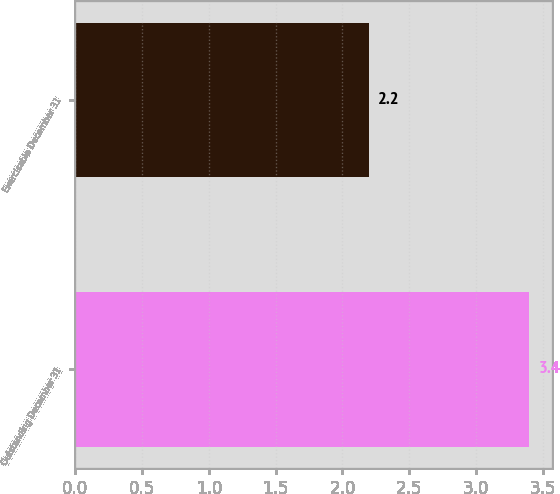Convert chart. <chart><loc_0><loc_0><loc_500><loc_500><bar_chart><fcel>Outstanding December 31<fcel>Exercisable December 31<nl><fcel>3.4<fcel>2.2<nl></chart> 